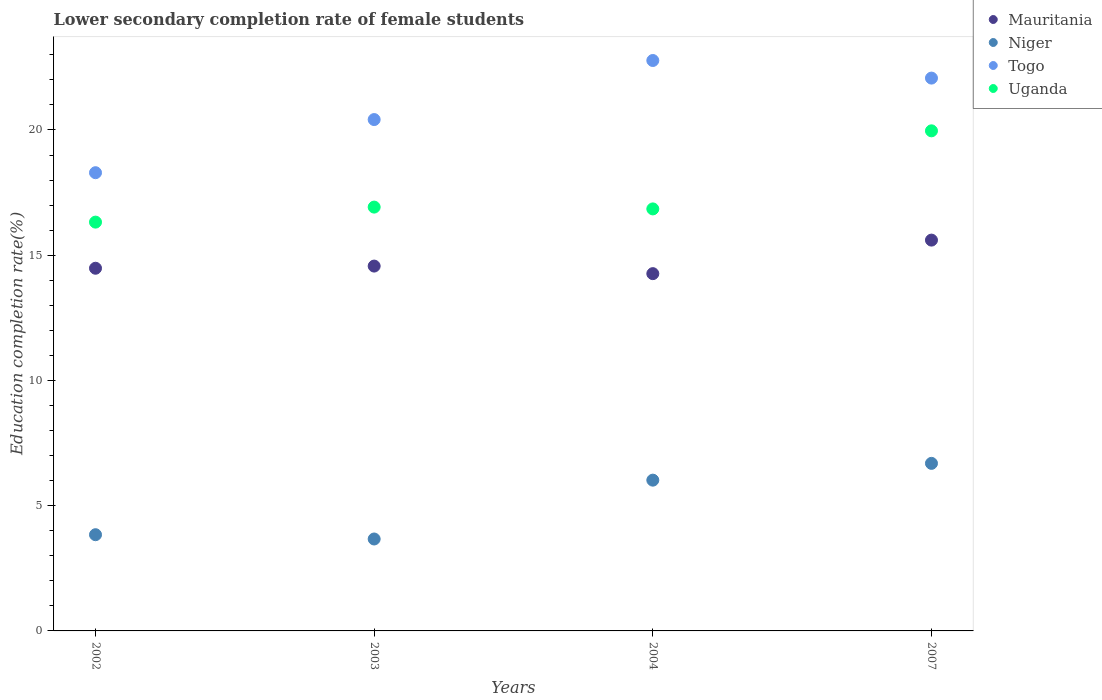Is the number of dotlines equal to the number of legend labels?
Keep it short and to the point. Yes. What is the lower secondary completion rate of female students in Niger in 2004?
Make the answer very short. 6.02. Across all years, what is the maximum lower secondary completion rate of female students in Mauritania?
Your response must be concise. 15.6. Across all years, what is the minimum lower secondary completion rate of female students in Niger?
Your answer should be very brief. 3.67. In which year was the lower secondary completion rate of female students in Uganda maximum?
Keep it short and to the point. 2007. What is the total lower secondary completion rate of female students in Uganda in the graph?
Make the answer very short. 70.05. What is the difference between the lower secondary completion rate of female students in Togo in 2003 and that in 2004?
Offer a very short reply. -2.36. What is the difference between the lower secondary completion rate of female students in Togo in 2004 and the lower secondary completion rate of female students in Niger in 2003?
Provide a succinct answer. 19.1. What is the average lower secondary completion rate of female students in Mauritania per year?
Give a very brief answer. 14.73. In the year 2007, what is the difference between the lower secondary completion rate of female students in Niger and lower secondary completion rate of female students in Mauritania?
Make the answer very short. -8.91. What is the ratio of the lower secondary completion rate of female students in Mauritania in 2002 to that in 2004?
Keep it short and to the point. 1.02. Is the lower secondary completion rate of female students in Togo in 2003 less than that in 2004?
Your answer should be very brief. Yes. What is the difference between the highest and the second highest lower secondary completion rate of female students in Niger?
Your answer should be compact. 0.67. What is the difference between the highest and the lowest lower secondary completion rate of female students in Togo?
Give a very brief answer. 4.48. In how many years, is the lower secondary completion rate of female students in Togo greater than the average lower secondary completion rate of female students in Togo taken over all years?
Provide a succinct answer. 2. Is the sum of the lower secondary completion rate of female students in Niger in 2004 and 2007 greater than the maximum lower secondary completion rate of female students in Togo across all years?
Provide a succinct answer. No. Is it the case that in every year, the sum of the lower secondary completion rate of female students in Togo and lower secondary completion rate of female students in Niger  is greater than the sum of lower secondary completion rate of female students in Uganda and lower secondary completion rate of female students in Mauritania?
Make the answer very short. No. Is it the case that in every year, the sum of the lower secondary completion rate of female students in Togo and lower secondary completion rate of female students in Mauritania  is greater than the lower secondary completion rate of female students in Uganda?
Provide a succinct answer. Yes. How many dotlines are there?
Offer a very short reply. 4. What is the difference between two consecutive major ticks on the Y-axis?
Provide a succinct answer. 5. Does the graph contain grids?
Offer a terse response. No. Where does the legend appear in the graph?
Offer a very short reply. Top right. How many legend labels are there?
Give a very brief answer. 4. What is the title of the graph?
Ensure brevity in your answer.  Lower secondary completion rate of female students. What is the label or title of the X-axis?
Make the answer very short. Years. What is the label or title of the Y-axis?
Provide a short and direct response. Education completion rate(%). What is the Education completion rate(%) of Mauritania in 2002?
Ensure brevity in your answer.  14.48. What is the Education completion rate(%) of Niger in 2002?
Your answer should be compact. 3.84. What is the Education completion rate(%) in Togo in 2002?
Ensure brevity in your answer.  18.29. What is the Education completion rate(%) of Uganda in 2002?
Provide a short and direct response. 16.32. What is the Education completion rate(%) of Mauritania in 2003?
Your response must be concise. 14.57. What is the Education completion rate(%) in Niger in 2003?
Ensure brevity in your answer.  3.67. What is the Education completion rate(%) in Togo in 2003?
Provide a short and direct response. 20.41. What is the Education completion rate(%) in Uganda in 2003?
Make the answer very short. 16.92. What is the Education completion rate(%) of Mauritania in 2004?
Your response must be concise. 14.26. What is the Education completion rate(%) in Niger in 2004?
Your response must be concise. 6.02. What is the Education completion rate(%) of Togo in 2004?
Ensure brevity in your answer.  22.77. What is the Education completion rate(%) in Uganda in 2004?
Offer a very short reply. 16.85. What is the Education completion rate(%) of Mauritania in 2007?
Offer a terse response. 15.6. What is the Education completion rate(%) of Niger in 2007?
Your response must be concise. 6.69. What is the Education completion rate(%) in Togo in 2007?
Your answer should be very brief. 22.07. What is the Education completion rate(%) in Uganda in 2007?
Your answer should be compact. 19.97. Across all years, what is the maximum Education completion rate(%) of Mauritania?
Give a very brief answer. 15.6. Across all years, what is the maximum Education completion rate(%) of Niger?
Offer a very short reply. 6.69. Across all years, what is the maximum Education completion rate(%) of Togo?
Your response must be concise. 22.77. Across all years, what is the maximum Education completion rate(%) in Uganda?
Offer a terse response. 19.97. Across all years, what is the minimum Education completion rate(%) in Mauritania?
Your response must be concise. 14.26. Across all years, what is the minimum Education completion rate(%) in Niger?
Offer a terse response. 3.67. Across all years, what is the minimum Education completion rate(%) of Togo?
Your answer should be compact. 18.29. Across all years, what is the minimum Education completion rate(%) of Uganda?
Your response must be concise. 16.32. What is the total Education completion rate(%) of Mauritania in the graph?
Keep it short and to the point. 58.91. What is the total Education completion rate(%) of Niger in the graph?
Make the answer very short. 20.22. What is the total Education completion rate(%) of Togo in the graph?
Provide a succinct answer. 83.55. What is the total Education completion rate(%) in Uganda in the graph?
Provide a succinct answer. 70.05. What is the difference between the Education completion rate(%) in Mauritania in 2002 and that in 2003?
Make the answer very short. -0.09. What is the difference between the Education completion rate(%) in Niger in 2002 and that in 2003?
Make the answer very short. 0.17. What is the difference between the Education completion rate(%) in Togo in 2002 and that in 2003?
Provide a succinct answer. -2.12. What is the difference between the Education completion rate(%) in Uganda in 2002 and that in 2003?
Offer a very short reply. -0.6. What is the difference between the Education completion rate(%) in Mauritania in 2002 and that in 2004?
Your response must be concise. 0.22. What is the difference between the Education completion rate(%) of Niger in 2002 and that in 2004?
Your response must be concise. -2.18. What is the difference between the Education completion rate(%) in Togo in 2002 and that in 2004?
Provide a succinct answer. -4.48. What is the difference between the Education completion rate(%) in Uganda in 2002 and that in 2004?
Offer a terse response. -0.53. What is the difference between the Education completion rate(%) of Mauritania in 2002 and that in 2007?
Keep it short and to the point. -1.12. What is the difference between the Education completion rate(%) of Niger in 2002 and that in 2007?
Ensure brevity in your answer.  -2.85. What is the difference between the Education completion rate(%) of Togo in 2002 and that in 2007?
Give a very brief answer. -3.78. What is the difference between the Education completion rate(%) in Uganda in 2002 and that in 2007?
Keep it short and to the point. -3.64. What is the difference between the Education completion rate(%) in Mauritania in 2003 and that in 2004?
Make the answer very short. 0.3. What is the difference between the Education completion rate(%) of Niger in 2003 and that in 2004?
Make the answer very short. -2.35. What is the difference between the Education completion rate(%) in Togo in 2003 and that in 2004?
Provide a succinct answer. -2.36. What is the difference between the Education completion rate(%) of Uganda in 2003 and that in 2004?
Ensure brevity in your answer.  0.07. What is the difference between the Education completion rate(%) of Mauritania in 2003 and that in 2007?
Keep it short and to the point. -1.04. What is the difference between the Education completion rate(%) of Niger in 2003 and that in 2007?
Offer a very short reply. -3.02. What is the difference between the Education completion rate(%) of Togo in 2003 and that in 2007?
Your answer should be compact. -1.66. What is the difference between the Education completion rate(%) of Uganda in 2003 and that in 2007?
Ensure brevity in your answer.  -3.04. What is the difference between the Education completion rate(%) in Mauritania in 2004 and that in 2007?
Provide a succinct answer. -1.34. What is the difference between the Education completion rate(%) in Niger in 2004 and that in 2007?
Your answer should be very brief. -0.67. What is the difference between the Education completion rate(%) in Togo in 2004 and that in 2007?
Provide a succinct answer. 0.7. What is the difference between the Education completion rate(%) in Uganda in 2004 and that in 2007?
Your response must be concise. -3.12. What is the difference between the Education completion rate(%) in Mauritania in 2002 and the Education completion rate(%) in Niger in 2003?
Make the answer very short. 10.81. What is the difference between the Education completion rate(%) of Mauritania in 2002 and the Education completion rate(%) of Togo in 2003?
Your answer should be very brief. -5.94. What is the difference between the Education completion rate(%) of Mauritania in 2002 and the Education completion rate(%) of Uganda in 2003?
Offer a terse response. -2.44. What is the difference between the Education completion rate(%) in Niger in 2002 and the Education completion rate(%) in Togo in 2003?
Offer a terse response. -16.57. What is the difference between the Education completion rate(%) in Niger in 2002 and the Education completion rate(%) in Uganda in 2003?
Give a very brief answer. -13.08. What is the difference between the Education completion rate(%) of Togo in 2002 and the Education completion rate(%) of Uganda in 2003?
Your answer should be very brief. 1.37. What is the difference between the Education completion rate(%) of Mauritania in 2002 and the Education completion rate(%) of Niger in 2004?
Keep it short and to the point. 8.46. What is the difference between the Education completion rate(%) of Mauritania in 2002 and the Education completion rate(%) of Togo in 2004?
Provide a short and direct response. -8.29. What is the difference between the Education completion rate(%) in Mauritania in 2002 and the Education completion rate(%) in Uganda in 2004?
Your answer should be very brief. -2.37. What is the difference between the Education completion rate(%) of Niger in 2002 and the Education completion rate(%) of Togo in 2004?
Ensure brevity in your answer.  -18.93. What is the difference between the Education completion rate(%) in Niger in 2002 and the Education completion rate(%) in Uganda in 2004?
Offer a very short reply. -13.01. What is the difference between the Education completion rate(%) in Togo in 2002 and the Education completion rate(%) in Uganda in 2004?
Your answer should be compact. 1.45. What is the difference between the Education completion rate(%) in Mauritania in 2002 and the Education completion rate(%) in Niger in 2007?
Make the answer very short. 7.79. What is the difference between the Education completion rate(%) of Mauritania in 2002 and the Education completion rate(%) of Togo in 2007?
Your answer should be very brief. -7.59. What is the difference between the Education completion rate(%) in Mauritania in 2002 and the Education completion rate(%) in Uganda in 2007?
Keep it short and to the point. -5.49. What is the difference between the Education completion rate(%) of Niger in 2002 and the Education completion rate(%) of Togo in 2007?
Offer a terse response. -18.23. What is the difference between the Education completion rate(%) of Niger in 2002 and the Education completion rate(%) of Uganda in 2007?
Offer a terse response. -16.12. What is the difference between the Education completion rate(%) in Togo in 2002 and the Education completion rate(%) in Uganda in 2007?
Provide a short and direct response. -1.67. What is the difference between the Education completion rate(%) of Mauritania in 2003 and the Education completion rate(%) of Niger in 2004?
Offer a terse response. 8.55. What is the difference between the Education completion rate(%) in Mauritania in 2003 and the Education completion rate(%) in Togo in 2004?
Your response must be concise. -8.21. What is the difference between the Education completion rate(%) in Mauritania in 2003 and the Education completion rate(%) in Uganda in 2004?
Keep it short and to the point. -2.28. What is the difference between the Education completion rate(%) in Niger in 2003 and the Education completion rate(%) in Togo in 2004?
Ensure brevity in your answer.  -19.1. What is the difference between the Education completion rate(%) of Niger in 2003 and the Education completion rate(%) of Uganda in 2004?
Provide a short and direct response. -13.18. What is the difference between the Education completion rate(%) of Togo in 2003 and the Education completion rate(%) of Uganda in 2004?
Your response must be concise. 3.57. What is the difference between the Education completion rate(%) of Mauritania in 2003 and the Education completion rate(%) of Niger in 2007?
Provide a succinct answer. 7.88. What is the difference between the Education completion rate(%) of Mauritania in 2003 and the Education completion rate(%) of Togo in 2007?
Your answer should be very brief. -7.5. What is the difference between the Education completion rate(%) in Mauritania in 2003 and the Education completion rate(%) in Uganda in 2007?
Your response must be concise. -5.4. What is the difference between the Education completion rate(%) in Niger in 2003 and the Education completion rate(%) in Togo in 2007?
Your answer should be compact. -18.4. What is the difference between the Education completion rate(%) of Niger in 2003 and the Education completion rate(%) of Uganda in 2007?
Ensure brevity in your answer.  -16.3. What is the difference between the Education completion rate(%) in Togo in 2003 and the Education completion rate(%) in Uganda in 2007?
Provide a succinct answer. 0.45. What is the difference between the Education completion rate(%) in Mauritania in 2004 and the Education completion rate(%) in Niger in 2007?
Keep it short and to the point. 7.57. What is the difference between the Education completion rate(%) of Mauritania in 2004 and the Education completion rate(%) of Togo in 2007?
Offer a very short reply. -7.81. What is the difference between the Education completion rate(%) in Mauritania in 2004 and the Education completion rate(%) in Uganda in 2007?
Provide a succinct answer. -5.7. What is the difference between the Education completion rate(%) in Niger in 2004 and the Education completion rate(%) in Togo in 2007?
Provide a short and direct response. -16.05. What is the difference between the Education completion rate(%) of Niger in 2004 and the Education completion rate(%) of Uganda in 2007?
Give a very brief answer. -13.95. What is the difference between the Education completion rate(%) in Togo in 2004 and the Education completion rate(%) in Uganda in 2007?
Keep it short and to the point. 2.81. What is the average Education completion rate(%) of Mauritania per year?
Your answer should be compact. 14.73. What is the average Education completion rate(%) of Niger per year?
Your answer should be compact. 5.05. What is the average Education completion rate(%) in Togo per year?
Ensure brevity in your answer.  20.89. What is the average Education completion rate(%) of Uganda per year?
Offer a very short reply. 17.51. In the year 2002, what is the difference between the Education completion rate(%) in Mauritania and Education completion rate(%) in Niger?
Provide a succinct answer. 10.64. In the year 2002, what is the difference between the Education completion rate(%) in Mauritania and Education completion rate(%) in Togo?
Give a very brief answer. -3.81. In the year 2002, what is the difference between the Education completion rate(%) of Mauritania and Education completion rate(%) of Uganda?
Offer a very short reply. -1.84. In the year 2002, what is the difference between the Education completion rate(%) in Niger and Education completion rate(%) in Togo?
Keep it short and to the point. -14.45. In the year 2002, what is the difference between the Education completion rate(%) of Niger and Education completion rate(%) of Uganda?
Your response must be concise. -12.48. In the year 2002, what is the difference between the Education completion rate(%) of Togo and Education completion rate(%) of Uganda?
Offer a very short reply. 1.97. In the year 2003, what is the difference between the Education completion rate(%) of Mauritania and Education completion rate(%) of Niger?
Offer a very short reply. 10.9. In the year 2003, what is the difference between the Education completion rate(%) in Mauritania and Education completion rate(%) in Togo?
Make the answer very short. -5.85. In the year 2003, what is the difference between the Education completion rate(%) of Mauritania and Education completion rate(%) of Uganda?
Your answer should be very brief. -2.35. In the year 2003, what is the difference between the Education completion rate(%) of Niger and Education completion rate(%) of Togo?
Ensure brevity in your answer.  -16.75. In the year 2003, what is the difference between the Education completion rate(%) in Niger and Education completion rate(%) in Uganda?
Your answer should be very brief. -13.25. In the year 2003, what is the difference between the Education completion rate(%) of Togo and Education completion rate(%) of Uganda?
Make the answer very short. 3.49. In the year 2004, what is the difference between the Education completion rate(%) of Mauritania and Education completion rate(%) of Niger?
Make the answer very short. 8.24. In the year 2004, what is the difference between the Education completion rate(%) in Mauritania and Education completion rate(%) in Togo?
Offer a terse response. -8.51. In the year 2004, what is the difference between the Education completion rate(%) in Mauritania and Education completion rate(%) in Uganda?
Offer a terse response. -2.58. In the year 2004, what is the difference between the Education completion rate(%) in Niger and Education completion rate(%) in Togo?
Offer a terse response. -16.75. In the year 2004, what is the difference between the Education completion rate(%) of Niger and Education completion rate(%) of Uganda?
Ensure brevity in your answer.  -10.83. In the year 2004, what is the difference between the Education completion rate(%) of Togo and Education completion rate(%) of Uganda?
Your response must be concise. 5.92. In the year 2007, what is the difference between the Education completion rate(%) of Mauritania and Education completion rate(%) of Niger?
Provide a succinct answer. 8.91. In the year 2007, what is the difference between the Education completion rate(%) of Mauritania and Education completion rate(%) of Togo?
Your response must be concise. -6.47. In the year 2007, what is the difference between the Education completion rate(%) in Mauritania and Education completion rate(%) in Uganda?
Ensure brevity in your answer.  -4.36. In the year 2007, what is the difference between the Education completion rate(%) in Niger and Education completion rate(%) in Togo?
Make the answer very short. -15.38. In the year 2007, what is the difference between the Education completion rate(%) in Niger and Education completion rate(%) in Uganda?
Offer a very short reply. -13.28. In the year 2007, what is the difference between the Education completion rate(%) of Togo and Education completion rate(%) of Uganda?
Offer a very short reply. 2.11. What is the ratio of the Education completion rate(%) in Mauritania in 2002 to that in 2003?
Your response must be concise. 0.99. What is the ratio of the Education completion rate(%) of Niger in 2002 to that in 2003?
Offer a terse response. 1.05. What is the ratio of the Education completion rate(%) of Togo in 2002 to that in 2003?
Give a very brief answer. 0.9. What is the ratio of the Education completion rate(%) in Uganda in 2002 to that in 2003?
Make the answer very short. 0.96. What is the ratio of the Education completion rate(%) of Mauritania in 2002 to that in 2004?
Offer a terse response. 1.02. What is the ratio of the Education completion rate(%) in Niger in 2002 to that in 2004?
Your answer should be compact. 0.64. What is the ratio of the Education completion rate(%) of Togo in 2002 to that in 2004?
Your answer should be compact. 0.8. What is the ratio of the Education completion rate(%) of Uganda in 2002 to that in 2004?
Make the answer very short. 0.97. What is the ratio of the Education completion rate(%) of Mauritania in 2002 to that in 2007?
Make the answer very short. 0.93. What is the ratio of the Education completion rate(%) of Niger in 2002 to that in 2007?
Keep it short and to the point. 0.57. What is the ratio of the Education completion rate(%) in Togo in 2002 to that in 2007?
Your response must be concise. 0.83. What is the ratio of the Education completion rate(%) of Uganda in 2002 to that in 2007?
Your answer should be very brief. 0.82. What is the ratio of the Education completion rate(%) of Mauritania in 2003 to that in 2004?
Offer a terse response. 1.02. What is the ratio of the Education completion rate(%) in Niger in 2003 to that in 2004?
Provide a short and direct response. 0.61. What is the ratio of the Education completion rate(%) of Togo in 2003 to that in 2004?
Give a very brief answer. 0.9. What is the ratio of the Education completion rate(%) in Uganda in 2003 to that in 2004?
Your response must be concise. 1. What is the ratio of the Education completion rate(%) of Mauritania in 2003 to that in 2007?
Keep it short and to the point. 0.93. What is the ratio of the Education completion rate(%) of Niger in 2003 to that in 2007?
Offer a very short reply. 0.55. What is the ratio of the Education completion rate(%) of Togo in 2003 to that in 2007?
Ensure brevity in your answer.  0.93. What is the ratio of the Education completion rate(%) in Uganda in 2003 to that in 2007?
Your answer should be compact. 0.85. What is the ratio of the Education completion rate(%) of Mauritania in 2004 to that in 2007?
Keep it short and to the point. 0.91. What is the ratio of the Education completion rate(%) in Niger in 2004 to that in 2007?
Provide a short and direct response. 0.9. What is the ratio of the Education completion rate(%) in Togo in 2004 to that in 2007?
Give a very brief answer. 1.03. What is the ratio of the Education completion rate(%) of Uganda in 2004 to that in 2007?
Provide a short and direct response. 0.84. What is the difference between the highest and the second highest Education completion rate(%) of Mauritania?
Ensure brevity in your answer.  1.04. What is the difference between the highest and the second highest Education completion rate(%) in Niger?
Your response must be concise. 0.67. What is the difference between the highest and the second highest Education completion rate(%) of Togo?
Provide a short and direct response. 0.7. What is the difference between the highest and the second highest Education completion rate(%) of Uganda?
Provide a succinct answer. 3.04. What is the difference between the highest and the lowest Education completion rate(%) in Mauritania?
Provide a short and direct response. 1.34. What is the difference between the highest and the lowest Education completion rate(%) of Niger?
Your answer should be compact. 3.02. What is the difference between the highest and the lowest Education completion rate(%) of Togo?
Offer a very short reply. 4.48. What is the difference between the highest and the lowest Education completion rate(%) in Uganda?
Offer a terse response. 3.64. 